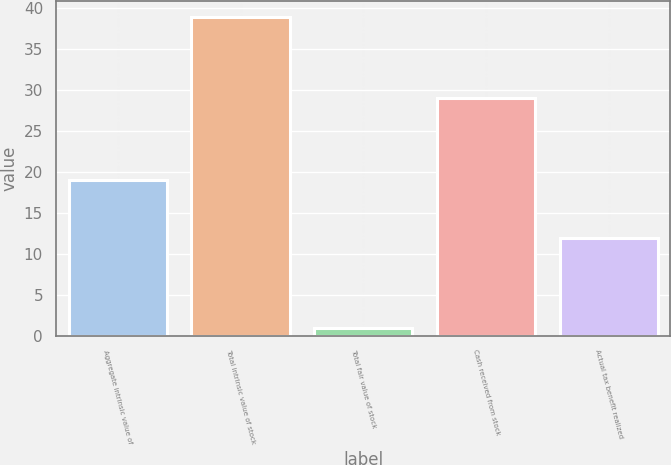Convert chart. <chart><loc_0><loc_0><loc_500><loc_500><bar_chart><fcel>Aggregate intrinsic value of<fcel>Total intrinsic value of stock<fcel>Total fair value of stock<fcel>Cash received from stock<fcel>Actual tax benefit realized<nl><fcel>19<fcel>39<fcel>1<fcel>29<fcel>12<nl></chart> 